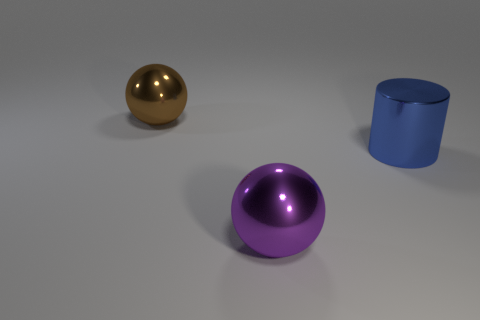There is a purple metal object that is the same size as the cylinder; what shape is it?
Your response must be concise. Sphere. Are there any other things that are the same color as the large metal cylinder?
Keep it short and to the point. No. There is a big purple object that is the same shape as the brown object; what material is it?
Your answer should be very brief. Metal. How many other objects are the same size as the brown sphere?
Ensure brevity in your answer.  2. There is a purple metal thing right of the big brown ball; is its shape the same as the large blue metal thing?
Give a very brief answer. No. How many other objects are there of the same shape as the large blue thing?
Provide a short and direct response. 0. The shiny thing that is left of the large purple ball has what shape?
Offer a terse response. Sphere. Is there another object made of the same material as the big brown object?
Offer a terse response. Yes. There is a metal ball that is in front of the blue thing; is its color the same as the large metal cylinder?
Keep it short and to the point. No. How big is the purple sphere?
Offer a very short reply. Large. 